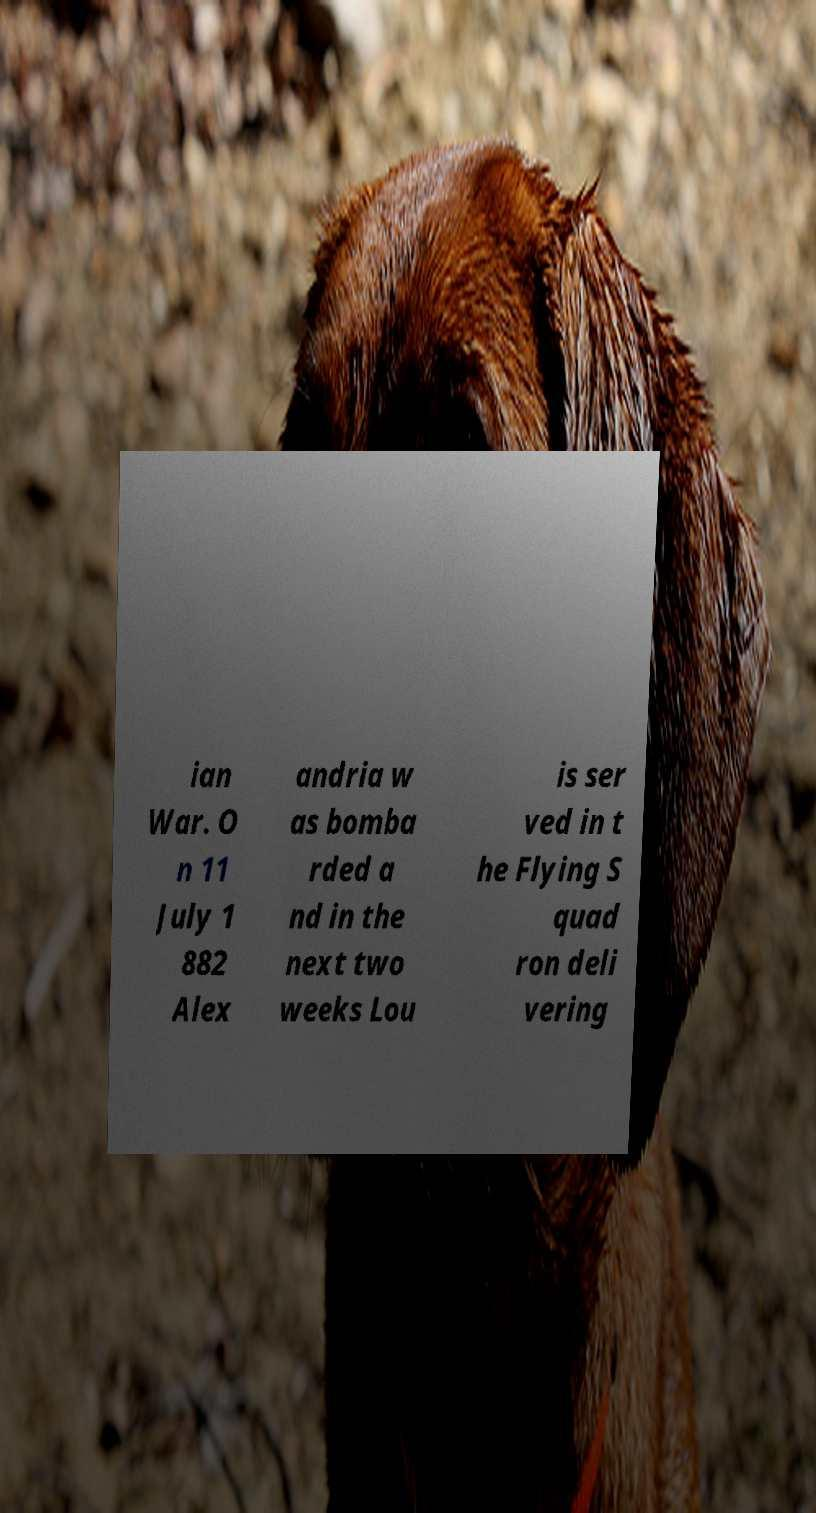Please identify and transcribe the text found in this image. ian War. O n 11 July 1 882 Alex andria w as bomba rded a nd in the next two weeks Lou is ser ved in t he Flying S quad ron deli vering 